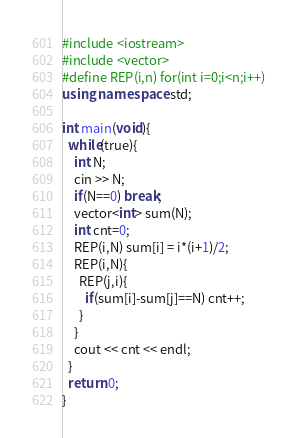<code> <loc_0><loc_0><loc_500><loc_500><_C++_>#include <iostream>
#include <vector>
#define REP(i,n) for(int i=0;i<n;i++)
using namespace std;

int main(void){
  while(true){
    int N;
    cin >> N;
    if(N==0) break;
    vector<int> sum(N);
    int cnt=0;
    REP(i,N) sum[i] = i*(i+1)/2;
    REP(i,N){
      REP(j,i){
        if(sum[i]-sum[j]==N) cnt++;
      }
    }
    cout << cnt << endl;
  }
  return 0;
}
</code> 